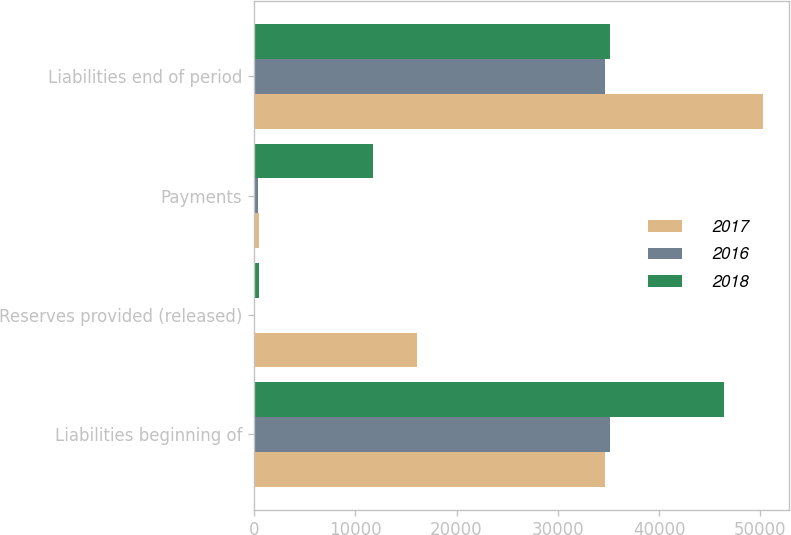Convert chart to OTSL. <chart><loc_0><loc_0><loc_500><loc_500><stacked_bar_chart><ecel><fcel>Liabilities beginning of<fcel>Reserves provided (released)<fcel>Payments<fcel>Liabilities end of period<nl><fcel>2017<fcel>34641<fcel>16130<fcel>489<fcel>50282<nl><fcel>2016<fcel>35114<fcel>50<fcel>423<fcel>34641<nl><fcel>2018<fcel>46381<fcel>506<fcel>11773<fcel>35114<nl></chart> 